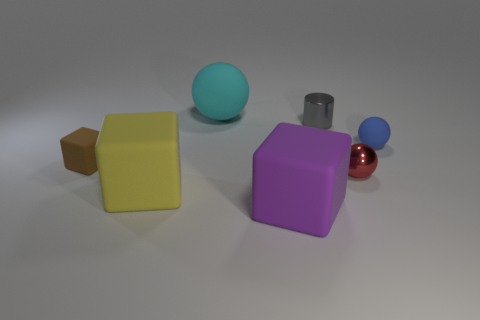Add 1 rubber balls. How many objects exist? 8 Subtract 1 spheres. How many spheres are left? 2 Subtract all cyan spheres. How many spheres are left? 2 Add 4 rubber things. How many rubber things exist? 9 Subtract all blue spheres. How many spheres are left? 2 Subtract 0 red cylinders. How many objects are left? 7 Subtract all cubes. How many objects are left? 4 Subtract all yellow cylinders. Subtract all cyan blocks. How many cylinders are left? 1 Subtract all blue cylinders. How many purple cubes are left? 1 Subtract all small blue objects. Subtract all large cubes. How many objects are left? 4 